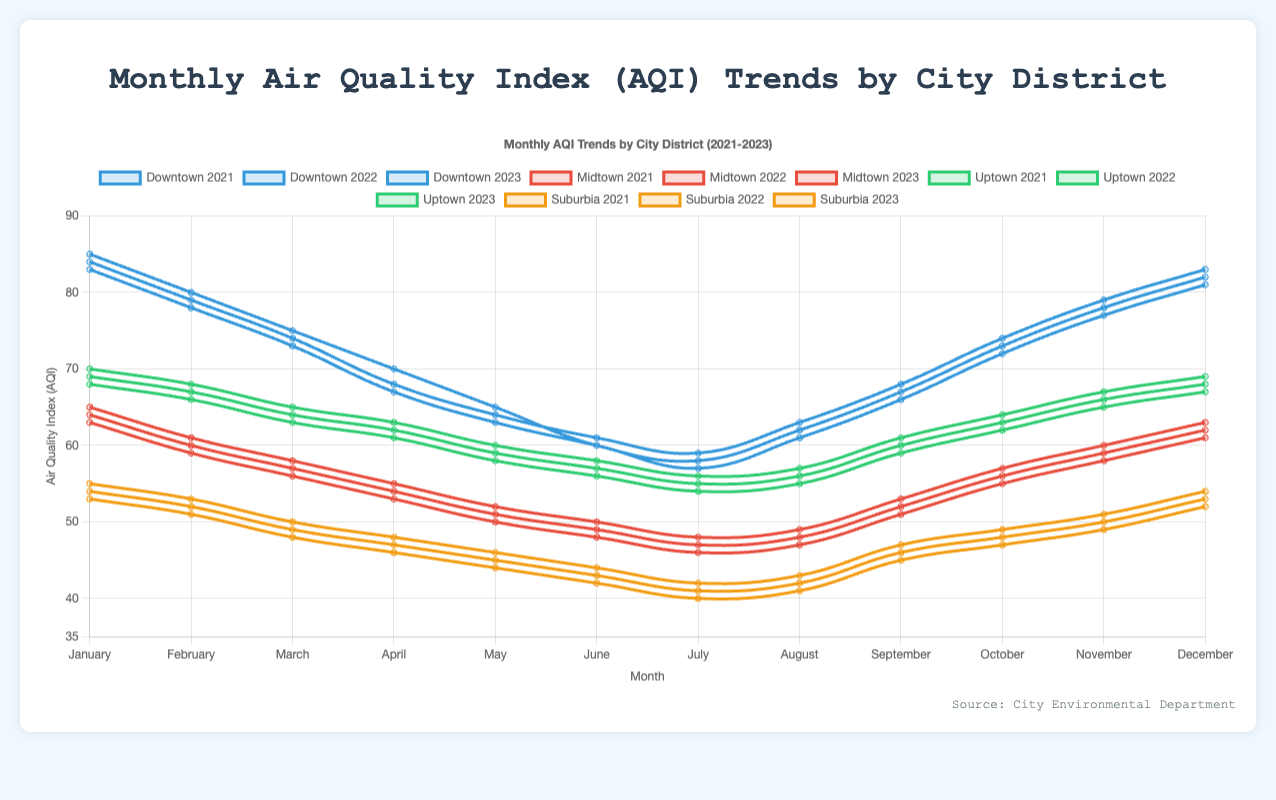What's the general trend of AQI in Downtown for the past three years? Over the past three years, the general trend of the AQI in Downtown shows a decreasing pattern from January to July followed by a slight increase from August to December. This pattern is consistent across 2021, 2022, and 2023.
Answer: Decreasing from January to July, then increasing Which district had the lowest AQI in July 2023? For July 2023, the AQI values for each district are as follows: Downtown 57, Midtown 46, Uptown 54, and Suburbia 40. Among these, Suburbia has the lowest AQI.
Answer: Suburbia Compare the AQI of Downtown and Midtown in December 2022. In December 2022, Downtown has an AQI of 83, while Midtown has an AQI of 62. Therefore, Downtown has a higher AQI than Midtown in December 2022.
Answer: Downtown What is the average AQI for Uptown in 2021? The AQI values for Uptown in 2021 are: 70, 68, 65, 63, 60, 58, 56, 57, 61, 64, 67, and 69. To find the average, sum these values (718) and divide by 12 (months). 718 / 12 = ~59.83.
Answer: ~59.83 In which month does Suburbia generally experience the lowest AQI each year? By observing the AQI values for Suburbia from 2021 to 2023, the lowest AQI consistently appears in July (42 for 2021, 41 for 2022, and 40 for 2023).
Answer: July Is there a month when all districts experienced an increase in AQI from the previous month in 2023? If yes, which month? By examining the AQI trends of each district, all districts show an increase in AQI from the previous month in August 2023 (Downtown: 61 from 57, Midtown: 47 from 46, Uptown: 55 from 54, Suburbia: 41 from 40).
Answer: August 2023 What is the largest year-over-year decrease in AQI for any district between January 2021 and January 2023? After examining the values:
- Downtown: 85 to 83 (decrease of 2)
- Midtown: 65 to 63 (decrease of 2)
- Uptown: 70 to 68 (decrease of 2)
- Suburbia: 55 to 53 (decrease of 2)
The largest decrease is 2 points for all districts.
Answer: 2 points for all districts How much higher was the AQI in Downtown compared to Suburbia in December 2023? The AQI in Downtown in December 2023 is 81, while in Suburbia, it is 52. The difference is 81 - 52 = 29.
Answer: 29 